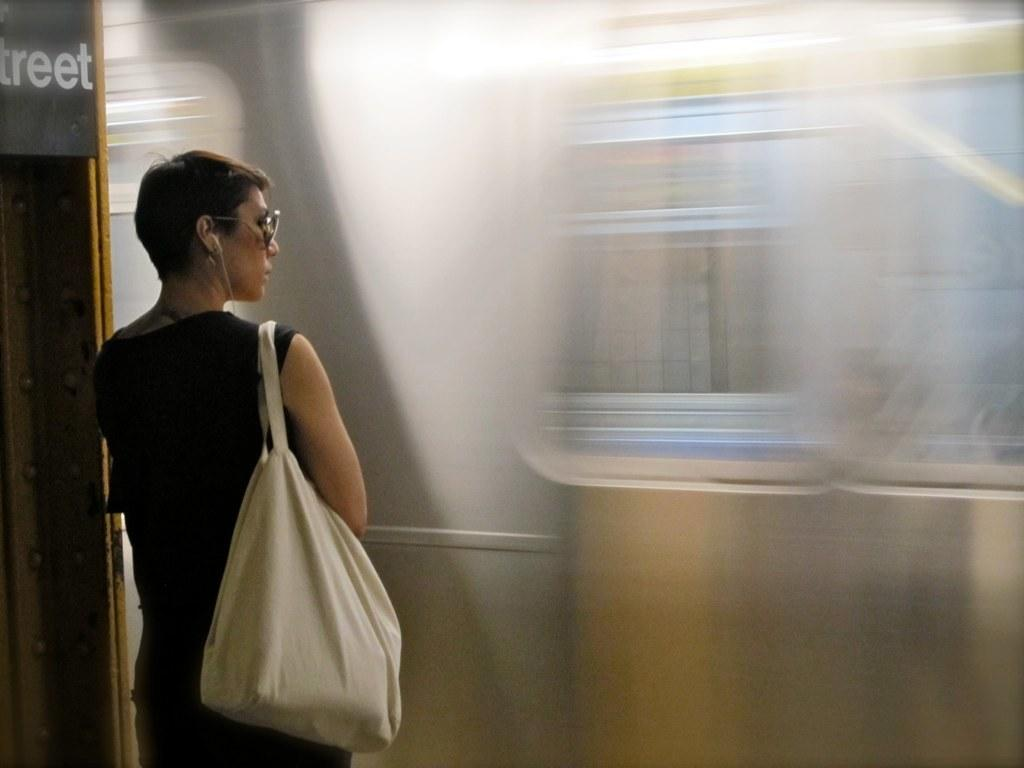Who is the main subject in the image? There is a woman in the image. Where is the woman located in the image? The woman is on the left side of the image. What is the woman doing in the image? The woman is standing. What is the woman carrying in the image? The woman is carrying a white color bag. What type of quilt is the woman using to cover her mind in the image? There is no quilt or mention of the woman's mind in the image. 